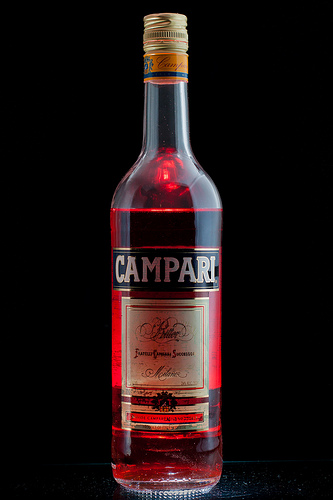<image>
Is there a label on the bottle? Yes. Looking at the image, I can see the label is positioned on top of the bottle, with the bottle providing support. 